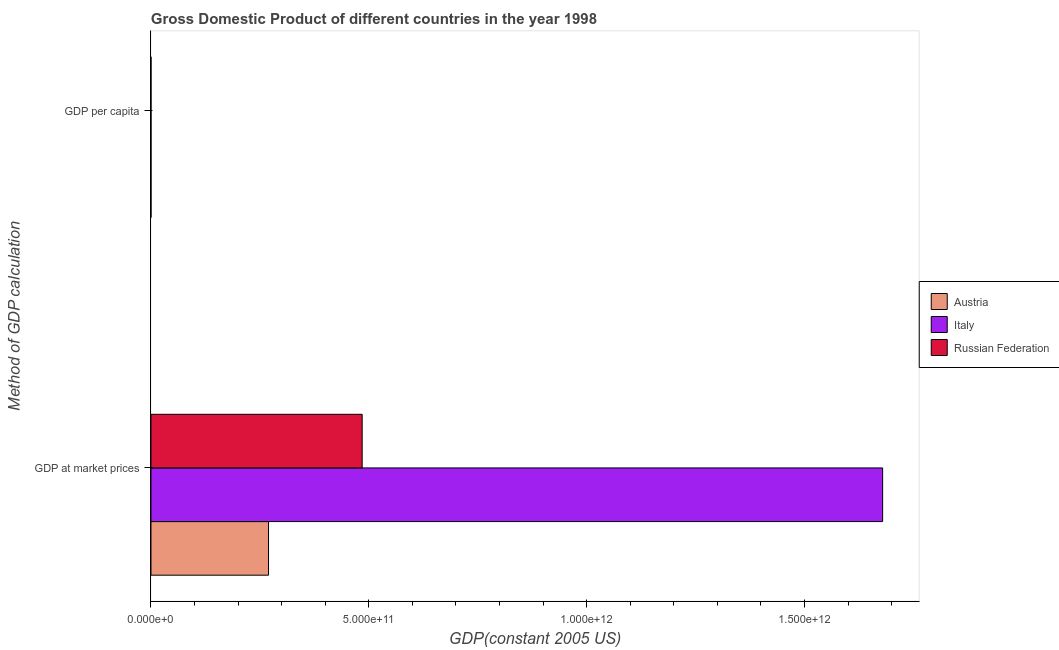How many different coloured bars are there?
Your answer should be very brief. 3. Are the number of bars on each tick of the Y-axis equal?
Give a very brief answer. Yes. What is the label of the 2nd group of bars from the top?
Your answer should be compact. GDP at market prices. What is the gdp at market prices in Austria?
Provide a short and direct response. 2.70e+11. Across all countries, what is the maximum gdp per capita?
Your answer should be very brief. 3.38e+04. Across all countries, what is the minimum gdp per capita?
Your answer should be very brief. 3282.86. In which country was the gdp at market prices maximum?
Offer a terse response. Italy. What is the total gdp per capita in the graph?
Provide a succinct answer. 6.66e+04. What is the difference between the gdp at market prices in Italy and that in Russian Federation?
Your answer should be compact. 1.19e+12. What is the difference between the gdp per capita in Austria and the gdp at market prices in Italy?
Keep it short and to the point. -1.68e+12. What is the average gdp at market prices per country?
Your response must be concise. 8.11e+11. What is the difference between the gdp at market prices and gdp per capita in Russian Federation?
Ensure brevity in your answer.  4.85e+11. In how many countries, is the gdp per capita greater than 1300000000000 US$?
Your answer should be compact. 0. What is the ratio of the gdp per capita in Italy to that in Austria?
Provide a succinct answer. 0.87. Is the gdp at market prices in Austria less than that in Russian Federation?
Make the answer very short. Yes. What does the 2nd bar from the top in GDP at market prices represents?
Keep it short and to the point. Italy. What does the 3rd bar from the bottom in GDP at market prices represents?
Give a very brief answer. Russian Federation. What is the difference between two consecutive major ticks on the X-axis?
Give a very brief answer. 5.00e+11. Are the values on the major ticks of X-axis written in scientific E-notation?
Offer a very short reply. Yes. Does the graph contain any zero values?
Your response must be concise. No. How many legend labels are there?
Your answer should be very brief. 3. How are the legend labels stacked?
Make the answer very short. Vertical. What is the title of the graph?
Your answer should be compact. Gross Domestic Product of different countries in the year 1998. Does "Germany" appear as one of the legend labels in the graph?
Keep it short and to the point. No. What is the label or title of the X-axis?
Your answer should be compact. GDP(constant 2005 US). What is the label or title of the Y-axis?
Offer a terse response. Method of GDP calculation. What is the GDP(constant 2005 US) in Austria in GDP at market prices?
Provide a short and direct response. 2.70e+11. What is the GDP(constant 2005 US) of Italy in GDP at market prices?
Your answer should be compact. 1.68e+12. What is the GDP(constant 2005 US) in Russian Federation in GDP at market prices?
Give a very brief answer. 4.85e+11. What is the GDP(constant 2005 US) of Austria in GDP per capita?
Your answer should be very brief. 3.38e+04. What is the GDP(constant 2005 US) of Italy in GDP per capita?
Your answer should be very brief. 2.95e+04. What is the GDP(constant 2005 US) in Russian Federation in GDP per capita?
Ensure brevity in your answer.  3282.86. Across all Method of GDP calculation, what is the maximum GDP(constant 2005 US) in Austria?
Your response must be concise. 2.70e+11. Across all Method of GDP calculation, what is the maximum GDP(constant 2005 US) in Italy?
Your answer should be very brief. 1.68e+12. Across all Method of GDP calculation, what is the maximum GDP(constant 2005 US) in Russian Federation?
Keep it short and to the point. 4.85e+11. Across all Method of GDP calculation, what is the minimum GDP(constant 2005 US) of Austria?
Provide a succinct answer. 3.38e+04. Across all Method of GDP calculation, what is the minimum GDP(constant 2005 US) in Italy?
Keep it short and to the point. 2.95e+04. Across all Method of GDP calculation, what is the minimum GDP(constant 2005 US) of Russian Federation?
Your answer should be very brief. 3282.86. What is the total GDP(constant 2005 US) of Austria in the graph?
Your answer should be very brief. 2.70e+11. What is the total GDP(constant 2005 US) of Italy in the graph?
Keep it short and to the point. 1.68e+12. What is the total GDP(constant 2005 US) in Russian Federation in the graph?
Offer a very short reply. 4.85e+11. What is the difference between the GDP(constant 2005 US) in Austria in GDP at market prices and that in GDP per capita?
Your answer should be compact. 2.70e+11. What is the difference between the GDP(constant 2005 US) of Italy in GDP at market prices and that in GDP per capita?
Your answer should be compact. 1.68e+12. What is the difference between the GDP(constant 2005 US) in Russian Federation in GDP at market prices and that in GDP per capita?
Offer a very short reply. 4.85e+11. What is the difference between the GDP(constant 2005 US) of Austria in GDP at market prices and the GDP(constant 2005 US) of Italy in GDP per capita?
Your response must be concise. 2.70e+11. What is the difference between the GDP(constant 2005 US) of Austria in GDP at market prices and the GDP(constant 2005 US) of Russian Federation in GDP per capita?
Offer a terse response. 2.70e+11. What is the difference between the GDP(constant 2005 US) in Italy in GDP at market prices and the GDP(constant 2005 US) in Russian Federation in GDP per capita?
Give a very brief answer. 1.68e+12. What is the average GDP(constant 2005 US) in Austria per Method of GDP calculation?
Provide a succinct answer. 1.35e+11. What is the average GDP(constant 2005 US) of Italy per Method of GDP calculation?
Ensure brevity in your answer.  8.40e+11. What is the average GDP(constant 2005 US) of Russian Federation per Method of GDP calculation?
Your response must be concise. 2.42e+11. What is the difference between the GDP(constant 2005 US) of Austria and GDP(constant 2005 US) of Italy in GDP at market prices?
Provide a short and direct response. -1.41e+12. What is the difference between the GDP(constant 2005 US) of Austria and GDP(constant 2005 US) of Russian Federation in GDP at market prices?
Your response must be concise. -2.15e+11. What is the difference between the GDP(constant 2005 US) in Italy and GDP(constant 2005 US) in Russian Federation in GDP at market prices?
Offer a very short reply. 1.19e+12. What is the difference between the GDP(constant 2005 US) in Austria and GDP(constant 2005 US) in Italy in GDP per capita?
Keep it short and to the point. 4317.1. What is the difference between the GDP(constant 2005 US) of Austria and GDP(constant 2005 US) of Russian Federation in GDP per capita?
Ensure brevity in your answer.  3.05e+04. What is the difference between the GDP(constant 2005 US) of Italy and GDP(constant 2005 US) of Russian Federation in GDP per capita?
Your response must be concise. 2.62e+04. What is the ratio of the GDP(constant 2005 US) in Austria in GDP at market prices to that in GDP per capita?
Offer a terse response. 7.98e+06. What is the ratio of the GDP(constant 2005 US) in Italy in GDP at market prices to that in GDP per capita?
Provide a succinct answer. 5.69e+07. What is the ratio of the GDP(constant 2005 US) of Russian Federation in GDP at market prices to that in GDP per capita?
Your answer should be very brief. 1.48e+08. What is the difference between the highest and the second highest GDP(constant 2005 US) of Austria?
Keep it short and to the point. 2.70e+11. What is the difference between the highest and the second highest GDP(constant 2005 US) in Italy?
Provide a succinct answer. 1.68e+12. What is the difference between the highest and the second highest GDP(constant 2005 US) in Russian Federation?
Make the answer very short. 4.85e+11. What is the difference between the highest and the lowest GDP(constant 2005 US) in Austria?
Your response must be concise. 2.70e+11. What is the difference between the highest and the lowest GDP(constant 2005 US) in Italy?
Provide a short and direct response. 1.68e+12. What is the difference between the highest and the lowest GDP(constant 2005 US) of Russian Federation?
Ensure brevity in your answer.  4.85e+11. 